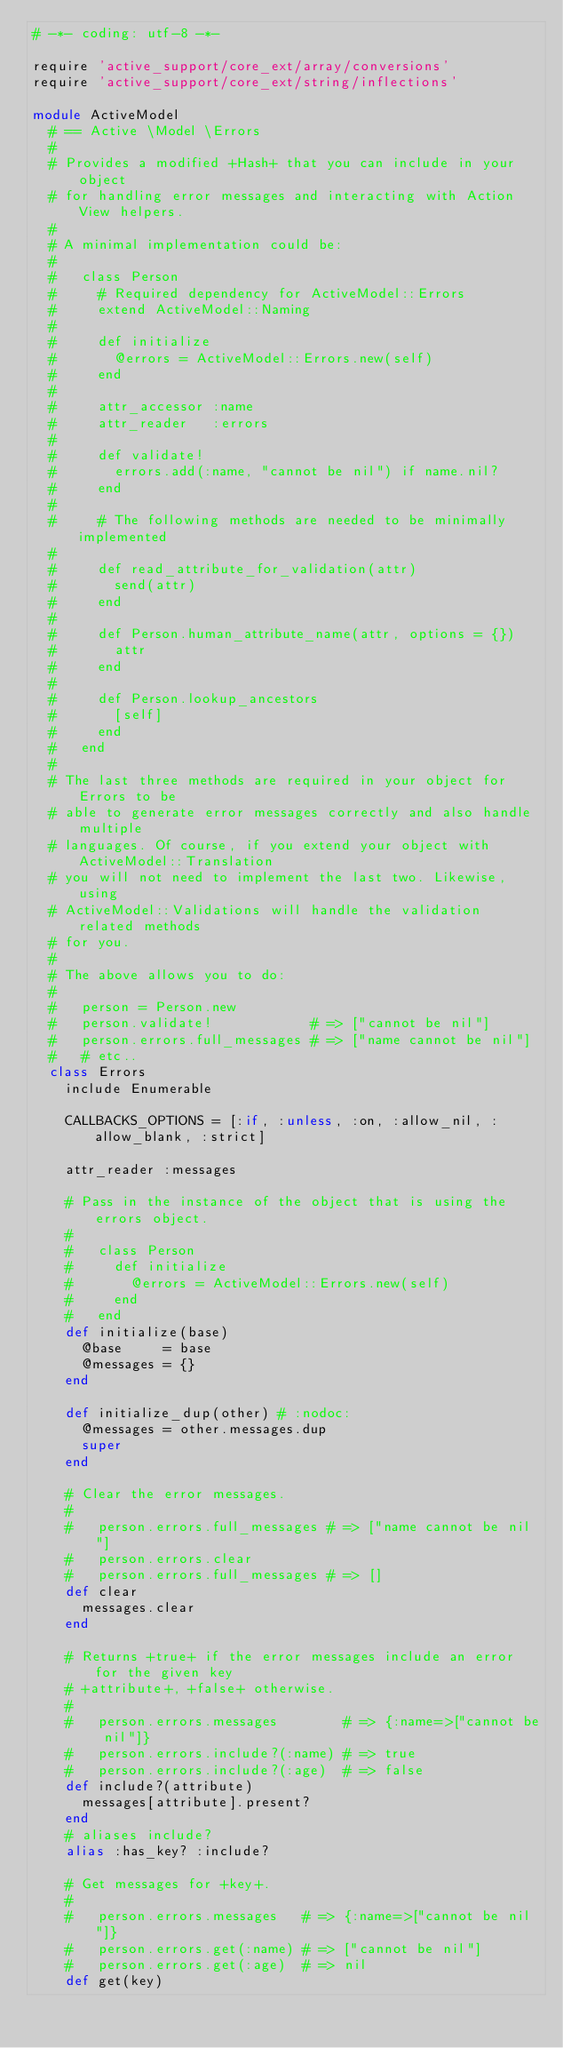Convert code to text. <code><loc_0><loc_0><loc_500><loc_500><_Ruby_># -*- coding: utf-8 -*-

require 'active_support/core_ext/array/conversions'
require 'active_support/core_ext/string/inflections'

module ActiveModel
  # == Active \Model \Errors
  #
  # Provides a modified +Hash+ that you can include in your object
  # for handling error messages and interacting with Action View helpers.
  #
  # A minimal implementation could be:
  #
  #   class Person
  #     # Required dependency for ActiveModel::Errors
  #     extend ActiveModel::Naming
  #
  #     def initialize
  #       @errors = ActiveModel::Errors.new(self)
  #     end
  #
  #     attr_accessor :name
  #     attr_reader   :errors
  #
  #     def validate!
  #       errors.add(:name, "cannot be nil") if name.nil?
  #     end
  #
  #     # The following methods are needed to be minimally implemented
  #
  #     def read_attribute_for_validation(attr)
  #       send(attr)
  #     end
  #
  #     def Person.human_attribute_name(attr, options = {})
  #       attr
  #     end
  #
  #     def Person.lookup_ancestors
  #       [self]
  #     end
  #   end
  #
  # The last three methods are required in your object for Errors to be
  # able to generate error messages correctly and also handle multiple
  # languages. Of course, if you extend your object with ActiveModel::Translation
  # you will not need to implement the last two. Likewise, using
  # ActiveModel::Validations will handle the validation related methods
  # for you.
  #
  # The above allows you to do:
  #
  #   person = Person.new
  #   person.validate!            # => ["cannot be nil"]
  #   person.errors.full_messages # => ["name cannot be nil"]
  #   # etc..
  class Errors
    include Enumerable

    CALLBACKS_OPTIONS = [:if, :unless, :on, :allow_nil, :allow_blank, :strict]

    attr_reader :messages

    # Pass in the instance of the object that is using the errors object.
    #
    #   class Person
    #     def initialize
    #       @errors = ActiveModel::Errors.new(self)
    #     end
    #   end
    def initialize(base)
      @base     = base
      @messages = {}
    end

    def initialize_dup(other) # :nodoc:
      @messages = other.messages.dup
      super
    end

    # Clear the error messages.
    #
    #   person.errors.full_messages # => ["name cannot be nil"]
    #   person.errors.clear
    #   person.errors.full_messages # => []
    def clear
      messages.clear
    end

    # Returns +true+ if the error messages include an error for the given key
    # +attribute+, +false+ otherwise.
    #
    #   person.errors.messages        # => {:name=>["cannot be nil"]}
    #   person.errors.include?(:name) # => true
    #   person.errors.include?(:age)  # => false
    def include?(attribute)
      messages[attribute].present?
    end
    # aliases include?
    alias :has_key? :include?

    # Get messages for +key+.
    #
    #   person.errors.messages   # => {:name=>["cannot be nil"]}
    #   person.errors.get(:name) # => ["cannot be nil"]
    #   person.errors.get(:age)  # => nil
    def get(key)</code> 